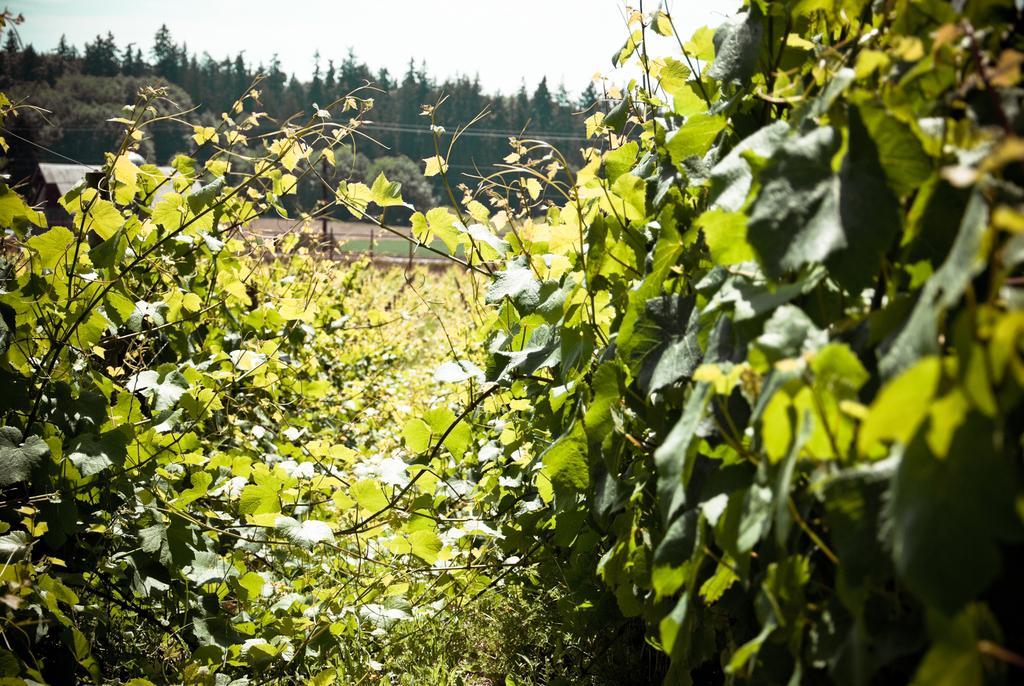How would you summarize this image in a sentence or two? In this image we can see the trees, plants and also the grass. Sky is also visible. 